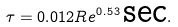Convert formula to latex. <formula><loc_0><loc_0><loc_500><loc_500>\tau = 0 . 0 1 2 R e ^ { 0 . 5 3 } \, \text {sec} .</formula> 